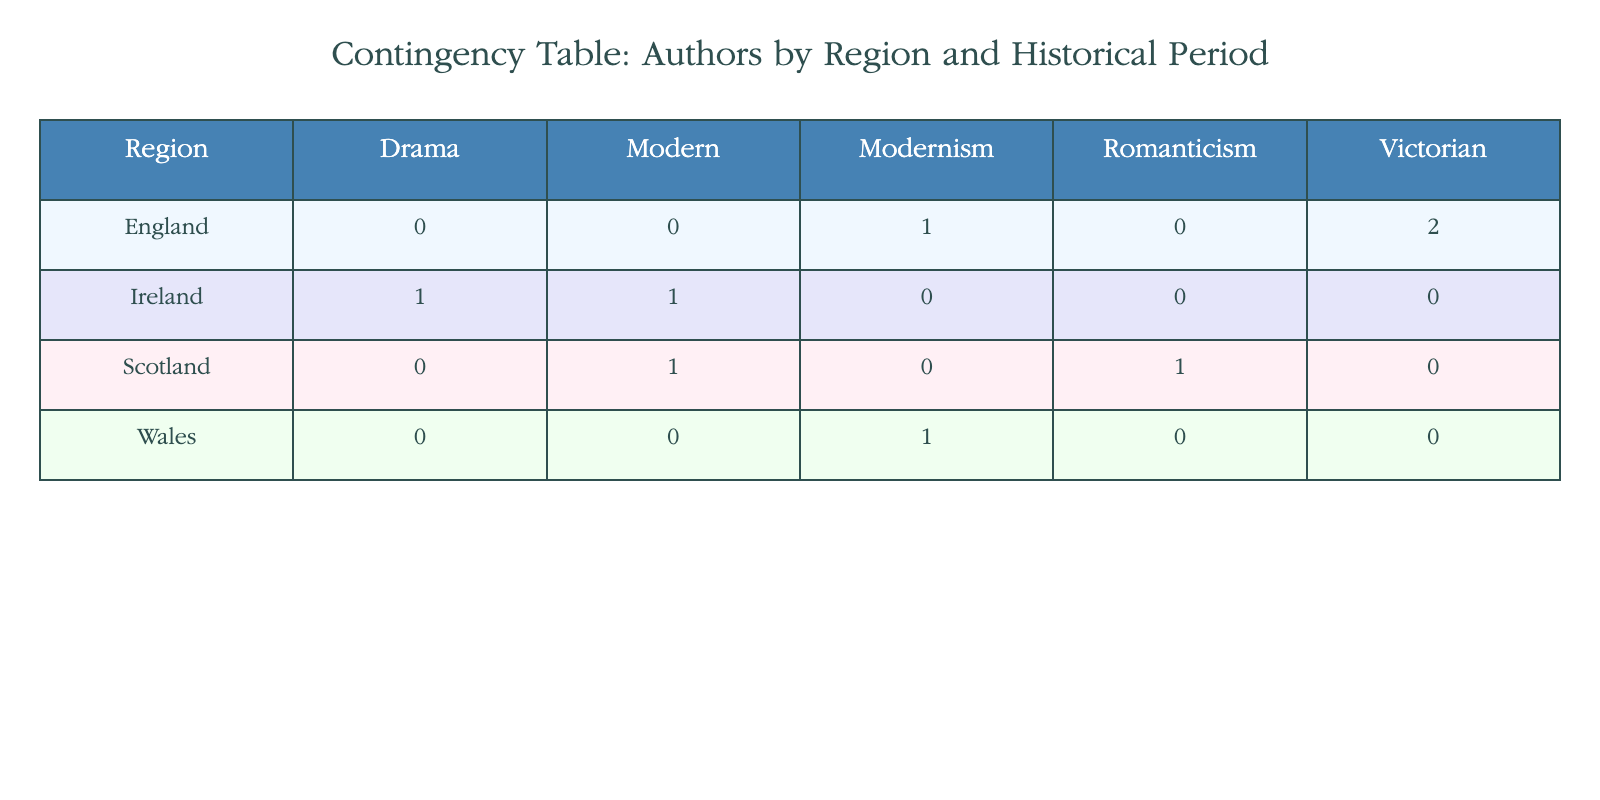What regions have authors from the Victorian period? By looking at the "Historical Period" column and focusing on the "Victorian" category, we see that the only region listed under this period is "England."
Answer: England How many authors are from Scotland? In the table, we identify two authors listed under the "Scotland" region: Robert Burns and John Buchan. Thus, there are two authors.
Answer: 2 Is there a modernist author from Wales? Checking the "Wales" row, we find that the author listed is Dylan Thomas, who is categorized as a "Modernism" author. Hence, there is a modernist author from Wales.
Answer: Yes Which historical period has the highest number of authors from England? By reviewing the "England" row, we see there are two authors from the Victorian period (Charles Dickens and George Eliot) and only one author from Modernism (Virginia Woolf). Therefore, the Victorian period has the highest number with two authors.
Answer: Victorian What is the total count of authors associated with Ireland? In the table, we see two authors from Ireland: James Joyce and Samuel Beckett. Therefore, the total count of authors associated with Ireland is two.
Answer: 2 Are there any authors from Scotland listed in the Romanticism period? In the "Scotland" region, the table includes Robert Burns categorized under "Romanticism." So, there is indeed an author from Scotland in this period.
Answer: Yes What is the difference in the number of authors between the Victorian and Modernism periods in England? In England, there are two authors from the Victorian period and one from Modernism. To find the difference, we subtract the number of Modernism authors (1) from the number of Victorian authors (2), resulting in a difference of 1.
Answer: 1 Which region has the most diverse historical periods represented in this table? By examining the regions, we note that "Scotland" features authors from both the Romanticism and Modern periods, while "Ireland" has Modern and Drama. In comparison, "England" has only Victorian and Modernism. Thus, "Scotland" shows the most diversity with two different historical periods represented.
Answer: Scotland 